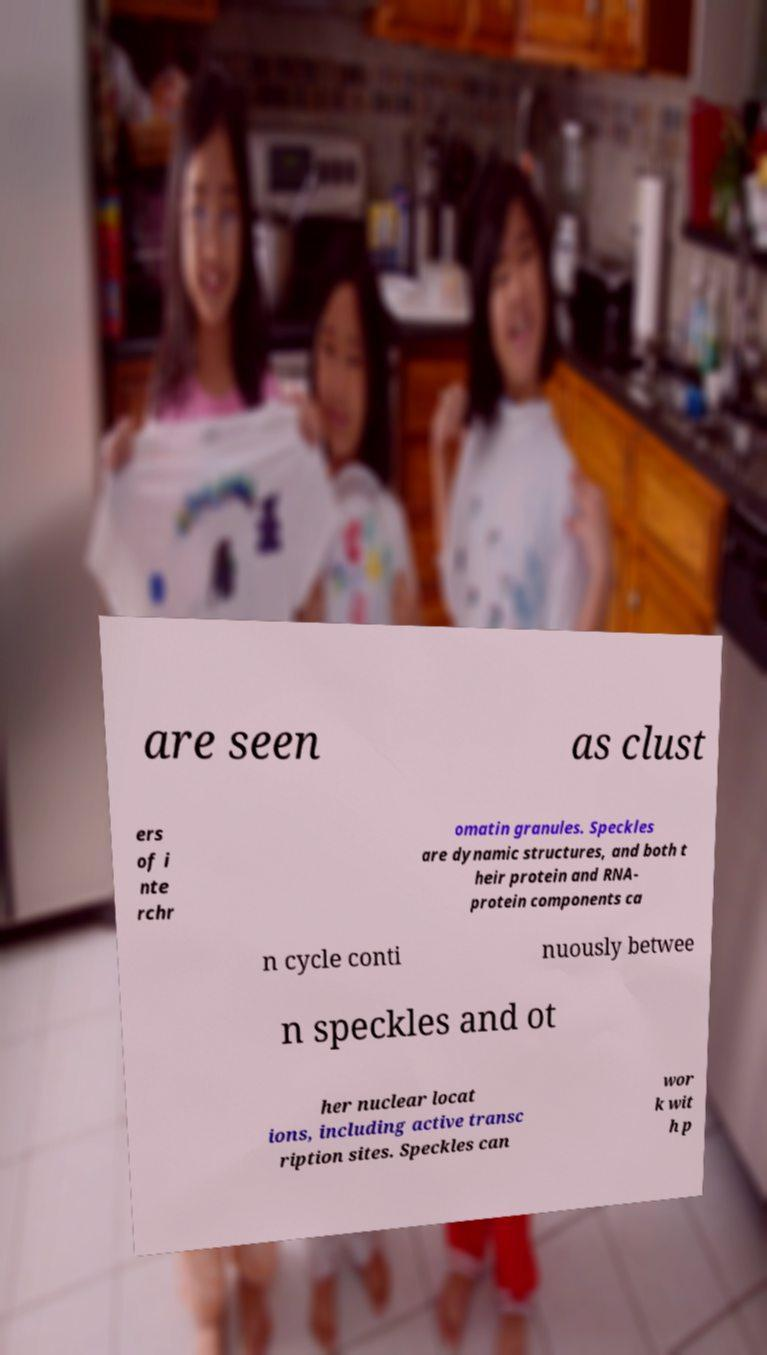Could you assist in decoding the text presented in this image and type it out clearly? are seen as clust ers of i nte rchr omatin granules. Speckles are dynamic structures, and both t heir protein and RNA- protein components ca n cycle conti nuously betwee n speckles and ot her nuclear locat ions, including active transc ription sites. Speckles can wor k wit h p 